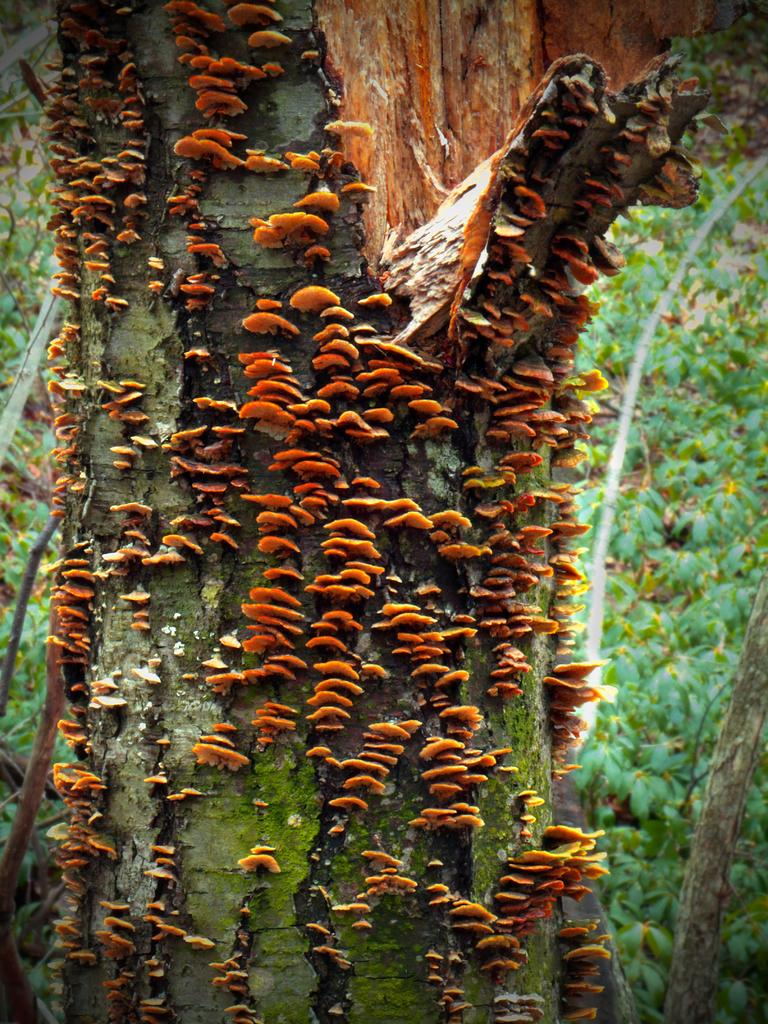Where was the image taken? The image was taken outdoors. What can be seen in the background of the image? There are many plants on the ground in the background. Can you describe a specific detail about a tree in the image? There is a branch of a tree with fungus on it. What type of cherry is hanging from the tree in the image? There are no cherries present in the image; it features a branch of a tree with fungus on it. Can you tell me how many mittens are visible in the image? There are no mittens present in the image. 